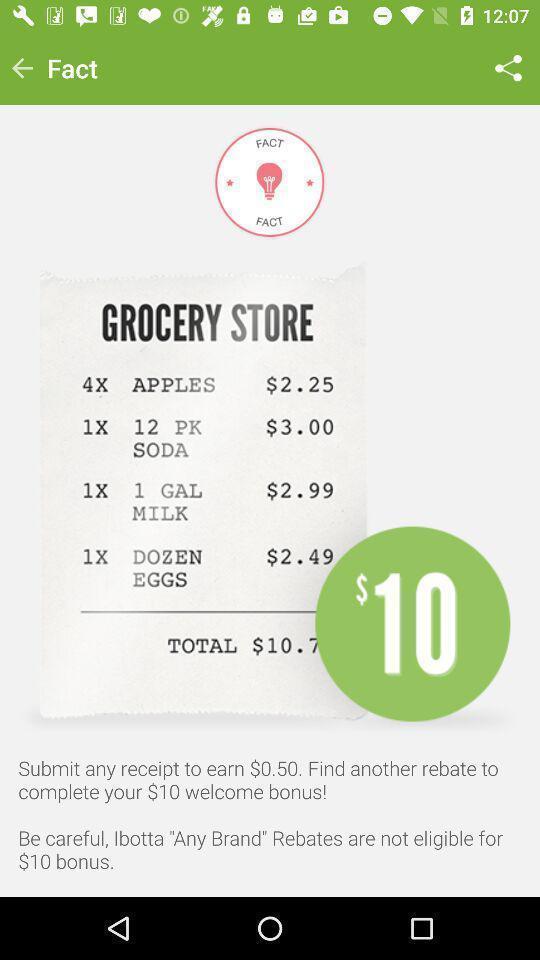What is the overall content of this screenshot? Page showing bill of products. 